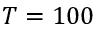Convert formula to latex. <formula><loc_0><loc_0><loc_500><loc_500>T = 1 0 0</formula> 